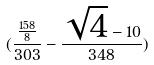Convert formula to latex. <formula><loc_0><loc_0><loc_500><loc_500>( \frac { \frac { 1 5 8 } { 8 } } { 3 0 3 } - \frac { \sqrt { 4 } - 1 0 } { 3 4 8 } )</formula> 